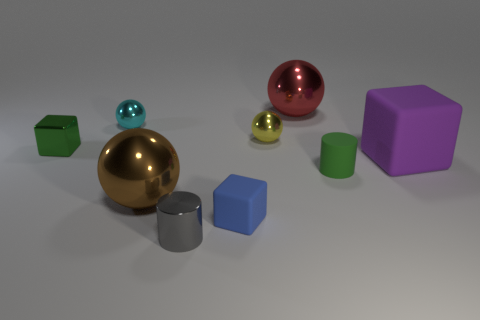Does the cube behind the big block have the same material as the small green thing on the right side of the yellow sphere?
Your answer should be very brief. No. What number of objects are big metal things left of the small blue cube or tiny shiny objects?
Ensure brevity in your answer.  5. Is the number of tiny blue rubber things in front of the blue rubber object less than the number of green metal cubes right of the tiny gray object?
Make the answer very short. No. How many other objects are the same size as the yellow metal ball?
Provide a succinct answer. 5. Does the yellow ball have the same material as the cube that is behind the purple object?
Your response must be concise. Yes. How many objects are either tiny cubes that are behind the large purple object or small green objects that are to the left of the small blue thing?
Offer a very short reply. 1. The large matte cube has what color?
Offer a very short reply. Purple. Are there fewer blocks in front of the purple cube than rubber blocks?
Keep it short and to the point. Yes. Is there a small shiny ball?
Your response must be concise. Yes. Are there fewer purple rubber objects than yellow matte things?
Ensure brevity in your answer.  No. 